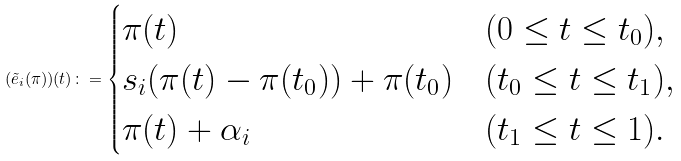Convert formula to latex. <formula><loc_0><loc_0><loc_500><loc_500>( \tilde { e } _ { i } ( \pi ) ) ( t ) \colon = \begin{cases} \pi ( t ) & ( 0 \leq t \leq t _ { 0 } ) , \\ s _ { i } ( \pi ( t ) - \pi ( t _ { 0 } ) ) + \pi ( t _ { 0 } ) & ( t _ { 0 } \leq t \leq t _ { 1 } ) , \\ \pi ( t ) + \alpha _ { i } & ( t _ { 1 } \leq t \leq 1 ) . \end{cases}</formula> 